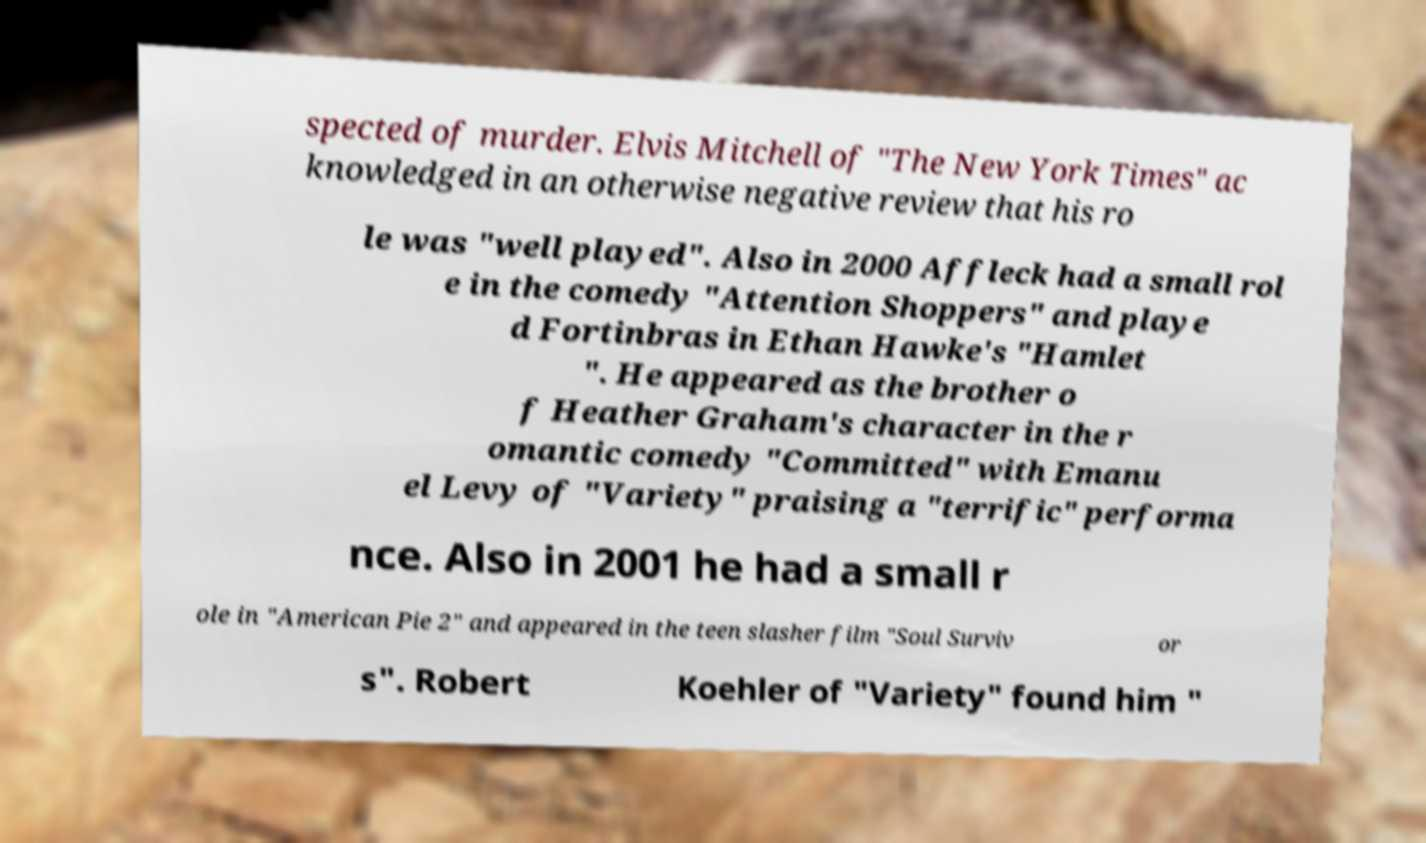There's text embedded in this image that I need extracted. Can you transcribe it verbatim? spected of murder. Elvis Mitchell of "The New York Times" ac knowledged in an otherwise negative review that his ro le was "well played". Also in 2000 Affleck had a small rol e in the comedy "Attention Shoppers" and playe d Fortinbras in Ethan Hawke's "Hamlet ". He appeared as the brother o f Heather Graham's character in the r omantic comedy "Committed" with Emanu el Levy of "Variety" praising a "terrific" performa nce. Also in 2001 he had a small r ole in "American Pie 2" and appeared in the teen slasher film "Soul Surviv or s". Robert Koehler of "Variety" found him " 